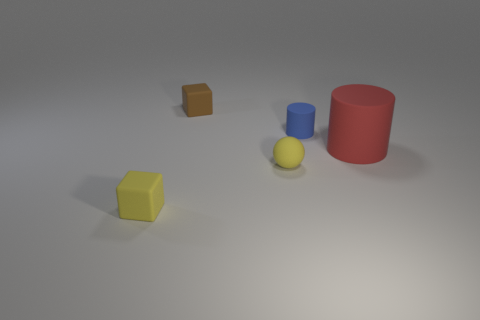There is a small block in front of the small brown matte cube; does it have the same color as the small cylinder that is behind the tiny yellow cube?
Your answer should be very brief. No. How many cubes are either large cyan metal things or large red objects?
Your answer should be compact. 0. Are there the same number of large red rubber cylinders that are in front of the large red matte object and small purple cubes?
Provide a succinct answer. Yes. The object that is in front of the yellow object right of the tiny block in front of the small brown rubber thing is made of what material?
Offer a very short reply. Rubber. What is the material of the tiny block that is the same color as the matte sphere?
Make the answer very short. Rubber. How many things are rubber cylinders that are to the left of the big matte object or brown metal cylinders?
Keep it short and to the point. 1. What number of things are either small matte cylinders or small things that are in front of the large red cylinder?
Your answer should be very brief. 3. There is a rubber block to the right of the tiny yellow thing that is to the left of the tiny yellow rubber sphere; how many big red matte cylinders are behind it?
Offer a very short reply. 0. What is the material of the brown thing that is the same size as the blue cylinder?
Your response must be concise. Rubber. Are there any other brown objects that have the same size as the brown rubber object?
Make the answer very short. No. 